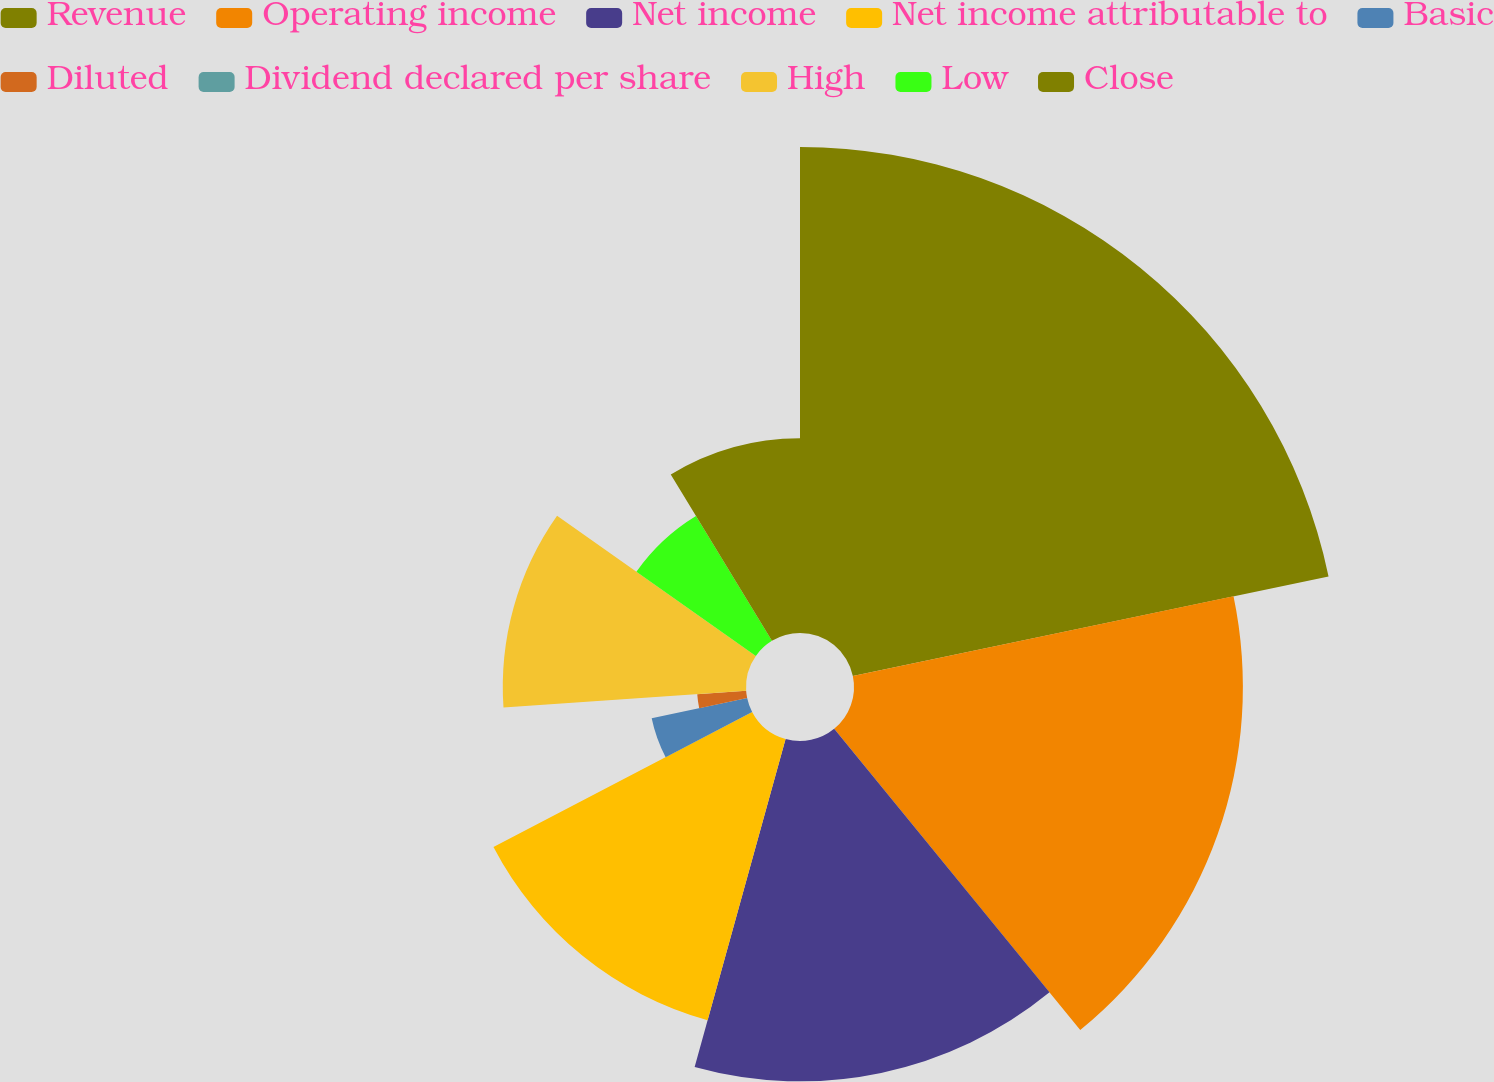Convert chart to OTSL. <chart><loc_0><loc_0><loc_500><loc_500><pie_chart><fcel>Revenue<fcel>Operating income<fcel>Net income<fcel>Net income attributable to<fcel>Basic<fcel>Diluted<fcel>Dividend declared per share<fcel>High<fcel>Low<fcel>Close<nl><fcel>21.72%<fcel>17.38%<fcel>15.21%<fcel>13.04%<fcel>4.36%<fcel>2.19%<fcel>0.01%<fcel>10.87%<fcel>6.53%<fcel>8.7%<nl></chart> 